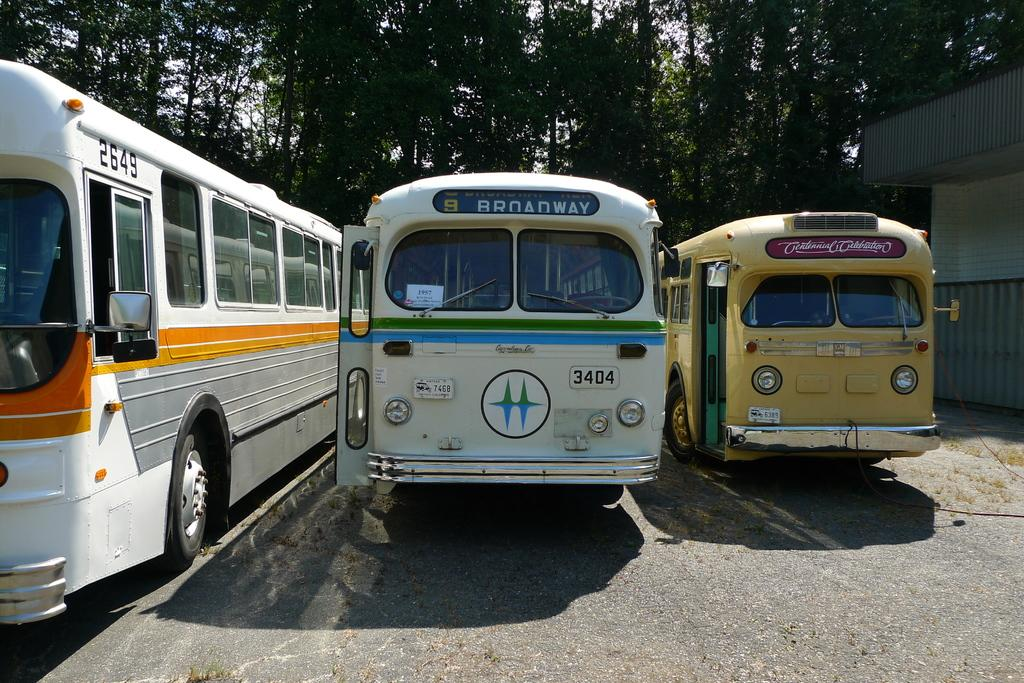What is the main subject in the center of the image? There are buses in the center of the image. What structure can be seen on the right side of the image? There is a house on the right side of the image. What type of natural elements are visible in the background of the image? There are trees in the background area of the image. How many brothers are playing on the board in the image? There is no board or brothers present in the image. 